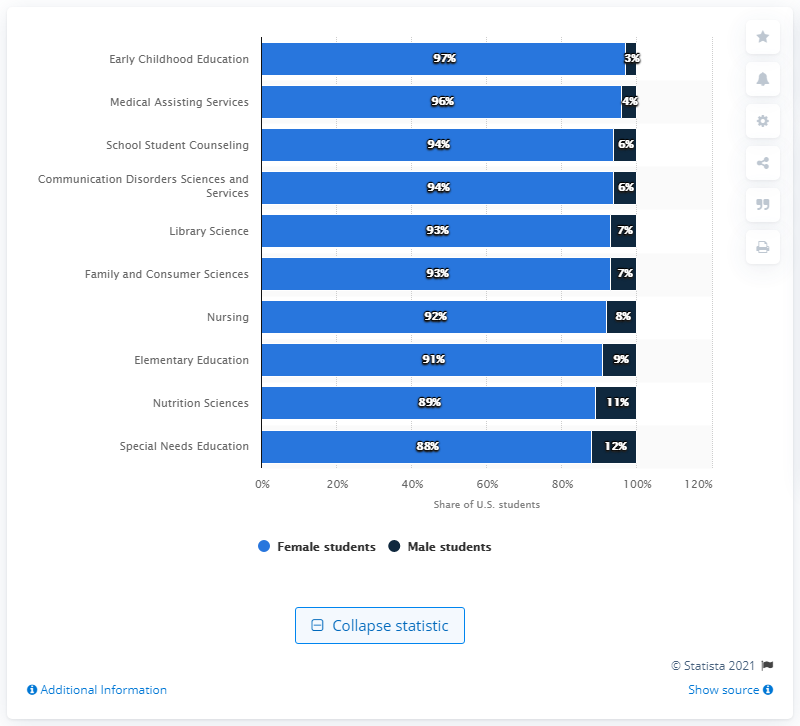Outline some significant characteristics in this image. In the department of early childhood development, 97% of the faculty members were women. 